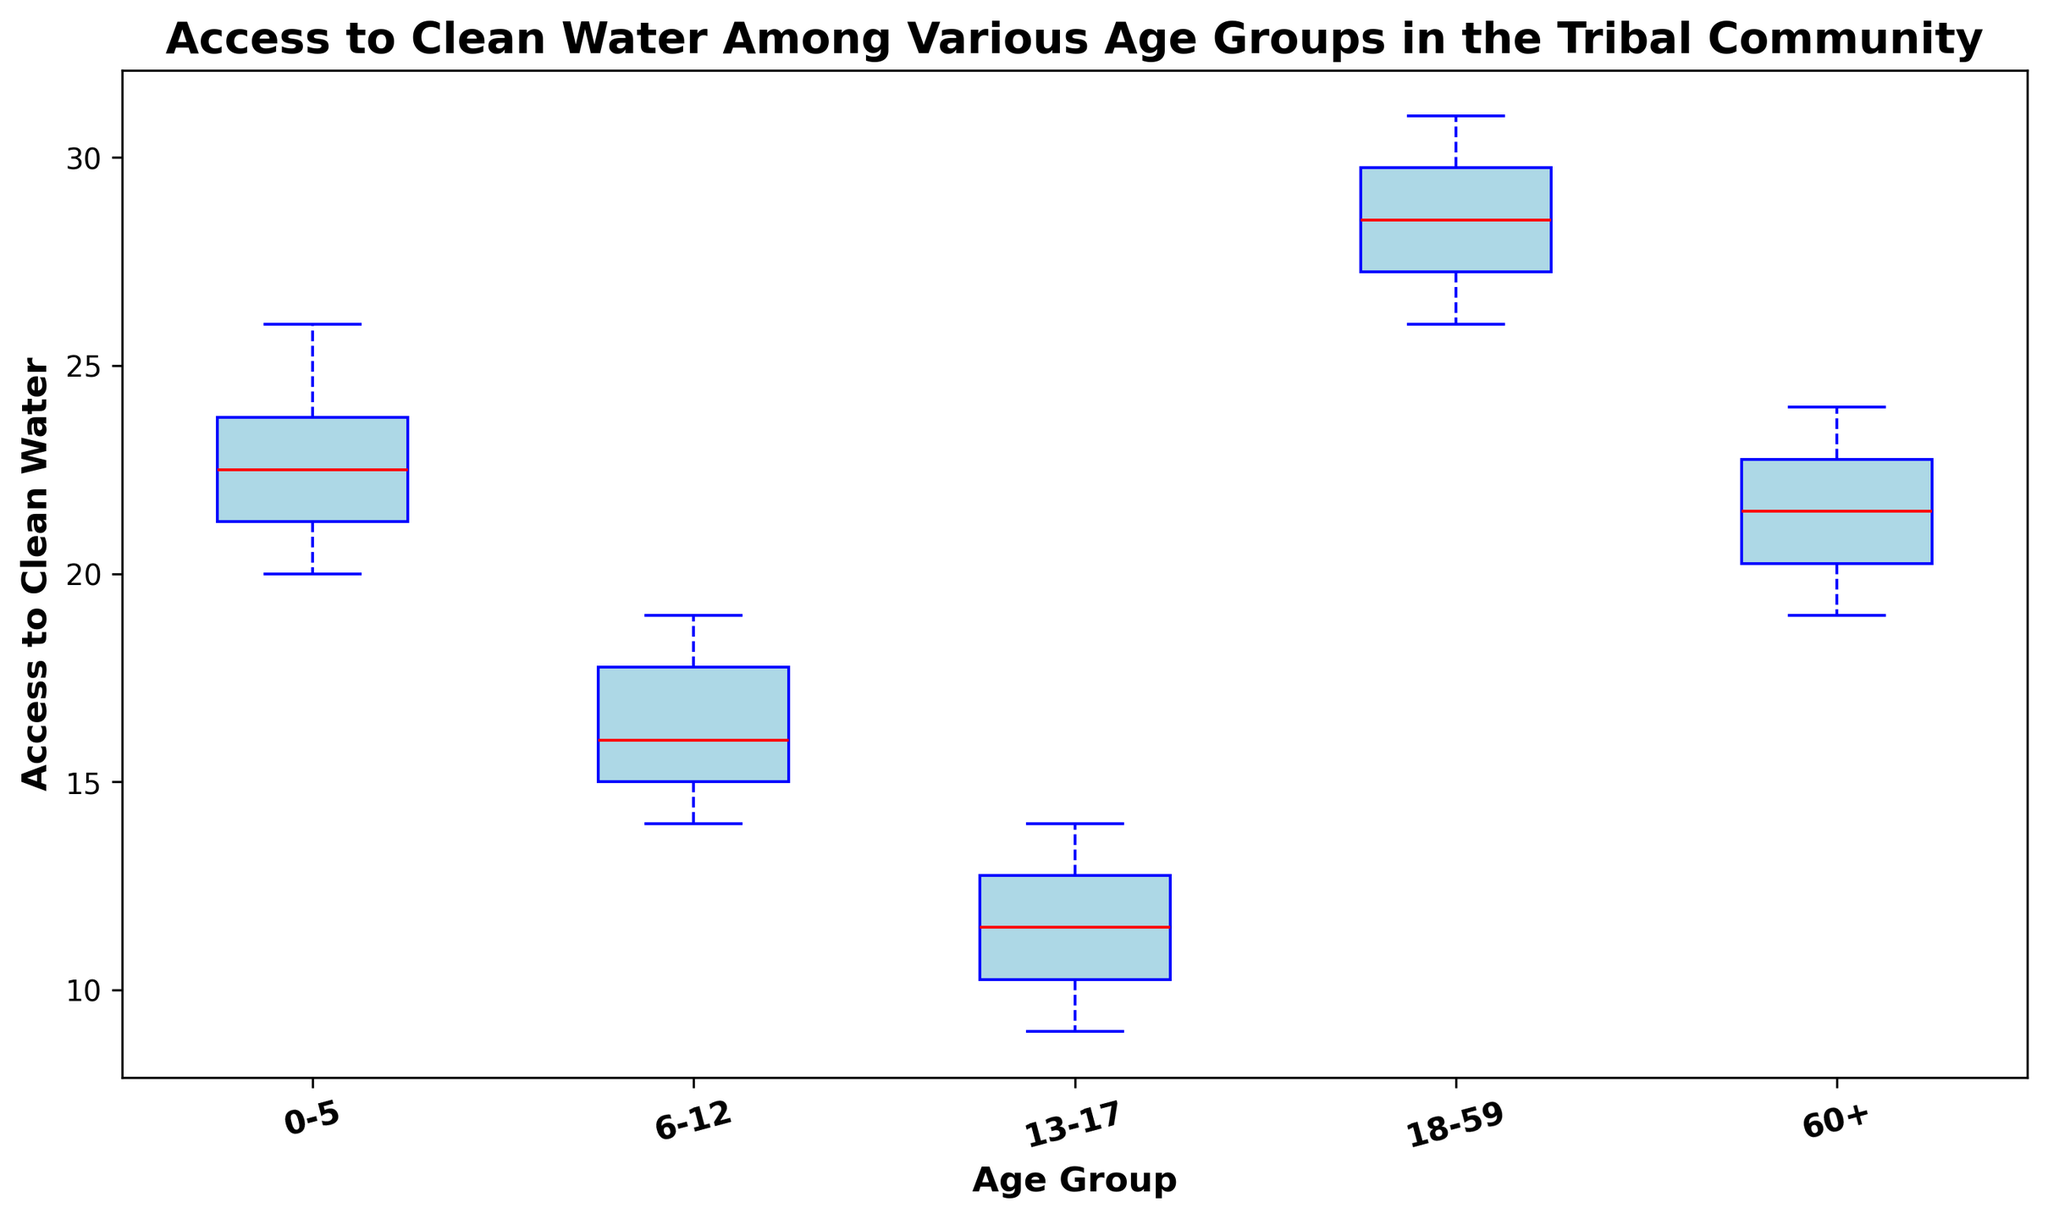What are the age groups shown in the box plot? The age groups are easily identified from the x-axis labels of the box plot. The x-axis represents the age groups.
Answer: 0-5, 6-12, 13-17, 18-59, 60+ Which age group has the highest median access to clean water? The median is represented by the red line inside each box. The highest median value appears in the 18-59 age group.
Answer: 18-59 Which age group has the lowest median access to clean water? By observing the red lines (medians) in the boxes, the lowest median is visible in the 13-17 age group.
Answer: 13-17 Compare the interquartile ranges (IQRs) of the 0-5 age group and the 13-17 age group. Which one is larger? The IQR can be observed as the height of the box. The IQR for the 0-5 age group is larger compared to the 13-17 age group.
Answer: 0-5 Which age group has the most variability in access to clean water? Variability is indicated by the range between the minimum and maximum whiskers. The 13-17 age group has shorter whiskers, indicating less variability compared to others. Thus, the 18-59 group has the most variability.
Answer: 18-59 How does the median access to clean water for the 60+ age group compare to that of the 0-5 age group? The red lines (medians) for both groups need to be compared. The median for the 60+ age group is slightly lower than the 0-5 age group.
Answer: 60+ is lower Is there an outlier in the data for any of the age groups? Outliers are shown by distinct points outside the whiskers. Visual inspection reveals no noticeable outliers in any age group.
Answer: No Which age groups have overlapping interquartile ranges (IQRs)? Overlapping IQRs can be seen when the boxes for different age groups share common y-value ranges. The 0-5 and 60+ age groups have overlapping IQRs, as do the 6-12 and 13-17 age groups.
Answer: 0-5 & 60+, 6-12 & 13-17 What is the approximate range of access to clean water for the 18-59 age group? The range spans from the minimum whisker to the maximum whisker. For the 18-59 age group, the range is approximately 26 to 31.
Answer: 26-31 Compare the whisker lengths of the 60+ age group and the 6-12 age group. Which one has longer whiskers? Whisker lengths are the lines extending from the top and bottom of the boxes. The 60+ age group has longer whiskers compared to the 6-12 age group.
Answer: 60+ 